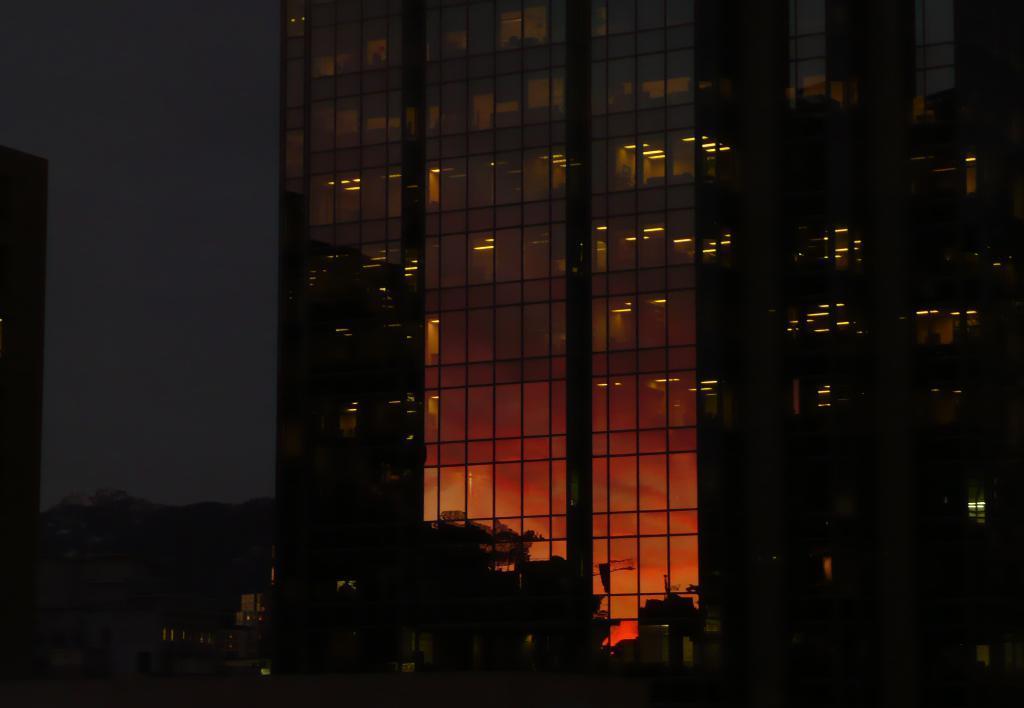Could you give a brief overview of what you see in this image? In this image we can see buildings with some lights. At the bottom we can see some trees. At the top of the image we can see the sky. 